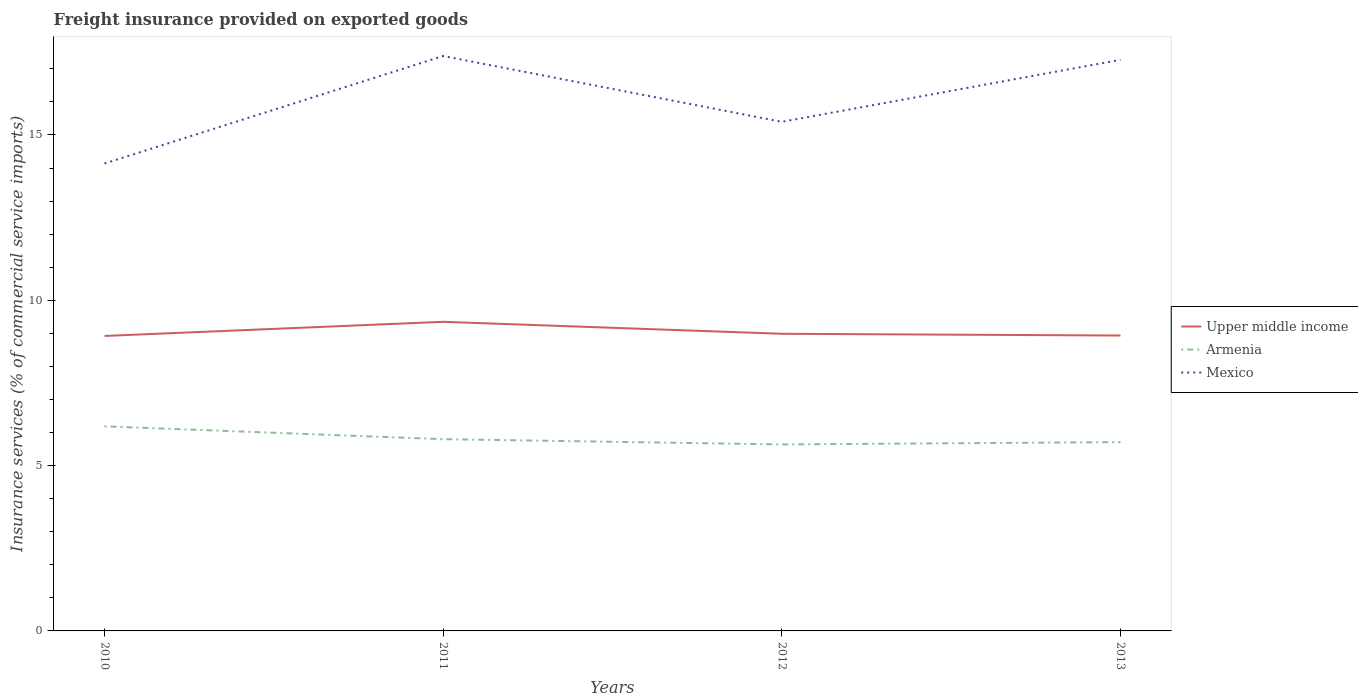Across all years, what is the maximum freight insurance provided on exported goods in Upper middle income?
Make the answer very short. 8.92. What is the total freight insurance provided on exported goods in Armenia in the graph?
Your answer should be very brief. 0.16. What is the difference between the highest and the second highest freight insurance provided on exported goods in Mexico?
Your answer should be very brief. 3.25. Is the freight insurance provided on exported goods in Armenia strictly greater than the freight insurance provided on exported goods in Upper middle income over the years?
Provide a short and direct response. Yes. How many lines are there?
Offer a terse response. 3. What is the difference between two consecutive major ticks on the Y-axis?
Provide a succinct answer. 5. Are the values on the major ticks of Y-axis written in scientific E-notation?
Keep it short and to the point. No. Does the graph contain any zero values?
Offer a terse response. No. Does the graph contain grids?
Provide a succinct answer. No. Where does the legend appear in the graph?
Offer a very short reply. Center right. How many legend labels are there?
Offer a very short reply. 3. What is the title of the graph?
Provide a short and direct response. Freight insurance provided on exported goods. What is the label or title of the X-axis?
Offer a very short reply. Years. What is the label or title of the Y-axis?
Make the answer very short. Insurance services (% of commercial service imports). What is the Insurance services (% of commercial service imports) of Upper middle income in 2010?
Provide a succinct answer. 8.92. What is the Insurance services (% of commercial service imports) in Armenia in 2010?
Provide a short and direct response. 6.19. What is the Insurance services (% of commercial service imports) in Mexico in 2010?
Offer a very short reply. 14.14. What is the Insurance services (% of commercial service imports) of Upper middle income in 2011?
Make the answer very short. 9.35. What is the Insurance services (% of commercial service imports) of Armenia in 2011?
Provide a succinct answer. 5.8. What is the Insurance services (% of commercial service imports) in Mexico in 2011?
Provide a short and direct response. 17.39. What is the Insurance services (% of commercial service imports) of Upper middle income in 2012?
Provide a short and direct response. 8.99. What is the Insurance services (% of commercial service imports) of Armenia in 2012?
Your response must be concise. 5.64. What is the Insurance services (% of commercial service imports) in Mexico in 2012?
Provide a short and direct response. 15.4. What is the Insurance services (% of commercial service imports) of Upper middle income in 2013?
Give a very brief answer. 8.93. What is the Insurance services (% of commercial service imports) of Armenia in 2013?
Your answer should be very brief. 5.71. What is the Insurance services (% of commercial service imports) in Mexico in 2013?
Keep it short and to the point. 17.27. Across all years, what is the maximum Insurance services (% of commercial service imports) of Upper middle income?
Give a very brief answer. 9.35. Across all years, what is the maximum Insurance services (% of commercial service imports) in Armenia?
Provide a short and direct response. 6.19. Across all years, what is the maximum Insurance services (% of commercial service imports) in Mexico?
Ensure brevity in your answer.  17.39. Across all years, what is the minimum Insurance services (% of commercial service imports) in Upper middle income?
Your response must be concise. 8.92. Across all years, what is the minimum Insurance services (% of commercial service imports) of Armenia?
Make the answer very short. 5.64. Across all years, what is the minimum Insurance services (% of commercial service imports) in Mexico?
Give a very brief answer. 14.14. What is the total Insurance services (% of commercial service imports) in Upper middle income in the graph?
Offer a very short reply. 36.19. What is the total Insurance services (% of commercial service imports) of Armenia in the graph?
Your answer should be compact. 23.34. What is the total Insurance services (% of commercial service imports) of Mexico in the graph?
Provide a succinct answer. 64.19. What is the difference between the Insurance services (% of commercial service imports) in Upper middle income in 2010 and that in 2011?
Offer a terse response. -0.43. What is the difference between the Insurance services (% of commercial service imports) of Armenia in 2010 and that in 2011?
Provide a short and direct response. 0.39. What is the difference between the Insurance services (% of commercial service imports) of Mexico in 2010 and that in 2011?
Provide a short and direct response. -3.25. What is the difference between the Insurance services (% of commercial service imports) in Upper middle income in 2010 and that in 2012?
Provide a succinct answer. -0.07. What is the difference between the Insurance services (% of commercial service imports) in Armenia in 2010 and that in 2012?
Provide a succinct answer. 0.55. What is the difference between the Insurance services (% of commercial service imports) in Mexico in 2010 and that in 2012?
Keep it short and to the point. -1.26. What is the difference between the Insurance services (% of commercial service imports) in Upper middle income in 2010 and that in 2013?
Your answer should be very brief. -0.01. What is the difference between the Insurance services (% of commercial service imports) of Armenia in 2010 and that in 2013?
Ensure brevity in your answer.  0.48. What is the difference between the Insurance services (% of commercial service imports) in Mexico in 2010 and that in 2013?
Ensure brevity in your answer.  -3.14. What is the difference between the Insurance services (% of commercial service imports) of Upper middle income in 2011 and that in 2012?
Your response must be concise. 0.36. What is the difference between the Insurance services (% of commercial service imports) in Armenia in 2011 and that in 2012?
Offer a terse response. 0.16. What is the difference between the Insurance services (% of commercial service imports) in Mexico in 2011 and that in 2012?
Keep it short and to the point. 1.99. What is the difference between the Insurance services (% of commercial service imports) of Upper middle income in 2011 and that in 2013?
Provide a succinct answer. 0.41. What is the difference between the Insurance services (% of commercial service imports) of Armenia in 2011 and that in 2013?
Provide a short and direct response. 0.09. What is the difference between the Insurance services (% of commercial service imports) in Mexico in 2011 and that in 2013?
Provide a short and direct response. 0.12. What is the difference between the Insurance services (% of commercial service imports) in Upper middle income in 2012 and that in 2013?
Keep it short and to the point. 0.05. What is the difference between the Insurance services (% of commercial service imports) in Armenia in 2012 and that in 2013?
Your response must be concise. -0.07. What is the difference between the Insurance services (% of commercial service imports) in Mexico in 2012 and that in 2013?
Your answer should be compact. -1.88. What is the difference between the Insurance services (% of commercial service imports) of Upper middle income in 2010 and the Insurance services (% of commercial service imports) of Armenia in 2011?
Keep it short and to the point. 3.12. What is the difference between the Insurance services (% of commercial service imports) in Upper middle income in 2010 and the Insurance services (% of commercial service imports) in Mexico in 2011?
Provide a short and direct response. -8.47. What is the difference between the Insurance services (% of commercial service imports) in Armenia in 2010 and the Insurance services (% of commercial service imports) in Mexico in 2011?
Offer a terse response. -11.2. What is the difference between the Insurance services (% of commercial service imports) of Upper middle income in 2010 and the Insurance services (% of commercial service imports) of Armenia in 2012?
Offer a very short reply. 3.28. What is the difference between the Insurance services (% of commercial service imports) of Upper middle income in 2010 and the Insurance services (% of commercial service imports) of Mexico in 2012?
Offer a very short reply. -6.48. What is the difference between the Insurance services (% of commercial service imports) of Armenia in 2010 and the Insurance services (% of commercial service imports) of Mexico in 2012?
Your response must be concise. -9.21. What is the difference between the Insurance services (% of commercial service imports) in Upper middle income in 2010 and the Insurance services (% of commercial service imports) in Armenia in 2013?
Provide a short and direct response. 3.21. What is the difference between the Insurance services (% of commercial service imports) of Upper middle income in 2010 and the Insurance services (% of commercial service imports) of Mexico in 2013?
Offer a terse response. -8.35. What is the difference between the Insurance services (% of commercial service imports) of Armenia in 2010 and the Insurance services (% of commercial service imports) of Mexico in 2013?
Give a very brief answer. -11.08. What is the difference between the Insurance services (% of commercial service imports) of Upper middle income in 2011 and the Insurance services (% of commercial service imports) of Armenia in 2012?
Your answer should be compact. 3.71. What is the difference between the Insurance services (% of commercial service imports) in Upper middle income in 2011 and the Insurance services (% of commercial service imports) in Mexico in 2012?
Give a very brief answer. -6.05. What is the difference between the Insurance services (% of commercial service imports) in Armenia in 2011 and the Insurance services (% of commercial service imports) in Mexico in 2012?
Provide a short and direct response. -9.6. What is the difference between the Insurance services (% of commercial service imports) of Upper middle income in 2011 and the Insurance services (% of commercial service imports) of Armenia in 2013?
Your answer should be compact. 3.64. What is the difference between the Insurance services (% of commercial service imports) in Upper middle income in 2011 and the Insurance services (% of commercial service imports) in Mexico in 2013?
Ensure brevity in your answer.  -7.92. What is the difference between the Insurance services (% of commercial service imports) of Armenia in 2011 and the Insurance services (% of commercial service imports) of Mexico in 2013?
Give a very brief answer. -11.47. What is the difference between the Insurance services (% of commercial service imports) in Upper middle income in 2012 and the Insurance services (% of commercial service imports) in Armenia in 2013?
Offer a very short reply. 3.28. What is the difference between the Insurance services (% of commercial service imports) of Upper middle income in 2012 and the Insurance services (% of commercial service imports) of Mexico in 2013?
Your answer should be very brief. -8.29. What is the difference between the Insurance services (% of commercial service imports) in Armenia in 2012 and the Insurance services (% of commercial service imports) in Mexico in 2013?
Make the answer very short. -11.63. What is the average Insurance services (% of commercial service imports) of Upper middle income per year?
Provide a succinct answer. 9.05. What is the average Insurance services (% of commercial service imports) in Armenia per year?
Make the answer very short. 5.83. What is the average Insurance services (% of commercial service imports) of Mexico per year?
Offer a very short reply. 16.05. In the year 2010, what is the difference between the Insurance services (% of commercial service imports) in Upper middle income and Insurance services (% of commercial service imports) in Armenia?
Provide a short and direct response. 2.73. In the year 2010, what is the difference between the Insurance services (% of commercial service imports) in Upper middle income and Insurance services (% of commercial service imports) in Mexico?
Offer a terse response. -5.22. In the year 2010, what is the difference between the Insurance services (% of commercial service imports) in Armenia and Insurance services (% of commercial service imports) in Mexico?
Give a very brief answer. -7.95. In the year 2011, what is the difference between the Insurance services (% of commercial service imports) in Upper middle income and Insurance services (% of commercial service imports) in Armenia?
Provide a succinct answer. 3.55. In the year 2011, what is the difference between the Insurance services (% of commercial service imports) in Upper middle income and Insurance services (% of commercial service imports) in Mexico?
Provide a short and direct response. -8.04. In the year 2011, what is the difference between the Insurance services (% of commercial service imports) in Armenia and Insurance services (% of commercial service imports) in Mexico?
Offer a very short reply. -11.59. In the year 2012, what is the difference between the Insurance services (% of commercial service imports) in Upper middle income and Insurance services (% of commercial service imports) in Armenia?
Offer a very short reply. 3.35. In the year 2012, what is the difference between the Insurance services (% of commercial service imports) of Upper middle income and Insurance services (% of commercial service imports) of Mexico?
Offer a terse response. -6.41. In the year 2012, what is the difference between the Insurance services (% of commercial service imports) in Armenia and Insurance services (% of commercial service imports) in Mexico?
Your response must be concise. -9.76. In the year 2013, what is the difference between the Insurance services (% of commercial service imports) of Upper middle income and Insurance services (% of commercial service imports) of Armenia?
Your answer should be compact. 3.22. In the year 2013, what is the difference between the Insurance services (% of commercial service imports) of Upper middle income and Insurance services (% of commercial service imports) of Mexico?
Offer a very short reply. -8.34. In the year 2013, what is the difference between the Insurance services (% of commercial service imports) in Armenia and Insurance services (% of commercial service imports) in Mexico?
Offer a terse response. -11.56. What is the ratio of the Insurance services (% of commercial service imports) of Upper middle income in 2010 to that in 2011?
Your response must be concise. 0.95. What is the ratio of the Insurance services (% of commercial service imports) of Armenia in 2010 to that in 2011?
Offer a terse response. 1.07. What is the ratio of the Insurance services (% of commercial service imports) of Mexico in 2010 to that in 2011?
Your answer should be compact. 0.81. What is the ratio of the Insurance services (% of commercial service imports) of Upper middle income in 2010 to that in 2012?
Make the answer very short. 0.99. What is the ratio of the Insurance services (% of commercial service imports) in Armenia in 2010 to that in 2012?
Give a very brief answer. 1.1. What is the ratio of the Insurance services (% of commercial service imports) in Mexico in 2010 to that in 2012?
Provide a short and direct response. 0.92. What is the ratio of the Insurance services (% of commercial service imports) of Upper middle income in 2010 to that in 2013?
Offer a terse response. 1. What is the ratio of the Insurance services (% of commercial service imports) of Armenia in 2010 to that in 2013?
Provide a succinct answer. 1.08. What is the ratio of the Insurance services (% of commercial service imports) in Mexico in 2010 to that in 2013?
Give a very brief answer. 0.82. What is the ratio of the Insurance services (% of commercial service imports) in Upper middle income in 2011 to that in 2012?
Offer a terse response. 1.04. What is the ratio of the Insurance services (% of commercial service imports) in Armenia in 2011 to that in 2012?
Offer a terse response. 1.03. What is the ratio of the Insurance services (% of commercial service imports) in Mexico in 2011 to that in 2012?
Keep it short and to the point. 1.13. What is the ratio of the Insurance services (% of commercial service imports) of Upper middle income in 2011 to that in 2013?
Your response must be concise. 1.05. What is the ratio of the Insurance services (% of commercial service imports) in Armenia in 2011 to that in 2013?
Provide a succinct answer. 1.02. What is the ratio of the Insurance services (% of commercial service imports) in Mexico in 2011 to that in 2013?
Provide a short and direct response. 1.01. What is the ratio of the Insurance services (% of commercial service imports) in Upper middle income in 2012 to that in 2013?
Your answer should be compact. 1.01. What is the ratio of the Insurance services (% of commercial service imports) of Mexico in 2012 to that in 2013?
Give a very brief answer. 0.89. What is the difference between the highest and the second highest Insurance services (% of commercial service imports) of Upper middle income?
Give a very brief answer. 0.36. What is the difference between the highest and the second highest Insurance services (% of commercial service imports) of Armenia?
Your answer should be very brief. 0.39. What is the difference between the highest and the second highest Insurance services (% of commercial service imports) of Mexico?
Your response must be concise. 0.12. What is the difference between the highest and the lowest Insurance services (% of commercial service imports) in Upper middle income?
Give a very brief answer. 0.43. What is the difference between the highest and the lowest Insurance services (% of commercial service imports) of Armenia?
Provide a succinct answer. 0.55. What is the difference between the highest and the lowest Insurance services (% of commercial service imports) in Mexico?
Keep it short and to the point. 3.25. 